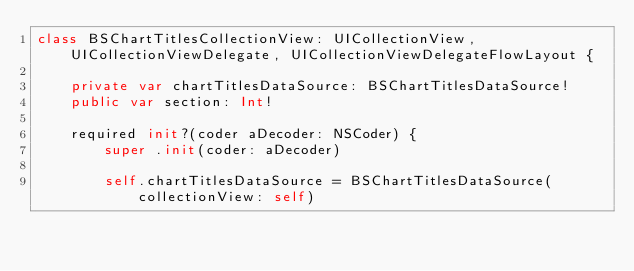<code> <loc_0><loc_0><loc_500><loc_500><_Swift_>class BSChartTitlesCollectionView: UICollectionView, UICollectionViewDelegate, UICollectionViewDelegateFlowLayout {

    private var chartTitlesDataSource: BSChartTitlesDataSource!
    public var section: Int!

    required init?(coder aDecoder: NSCoder) {
        super .init(coder: aDecoder)
        
        self.chartTitlesDataSource = BSChartTitlesDataSource(collectionView: self)</code> 